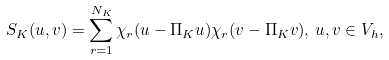<formula> <loc_0><loc_0><loc_500><loc_500>S _ { K } ( u , v ) = \sum _ { r = 1 } ^ { N _ { K } } \chi _ { r } ( u - \Pi _ { K } u ) \chi _ { r } ( v - \Pi _ { K } v ) , \, u , v \in V _ { h } ,</formula> 